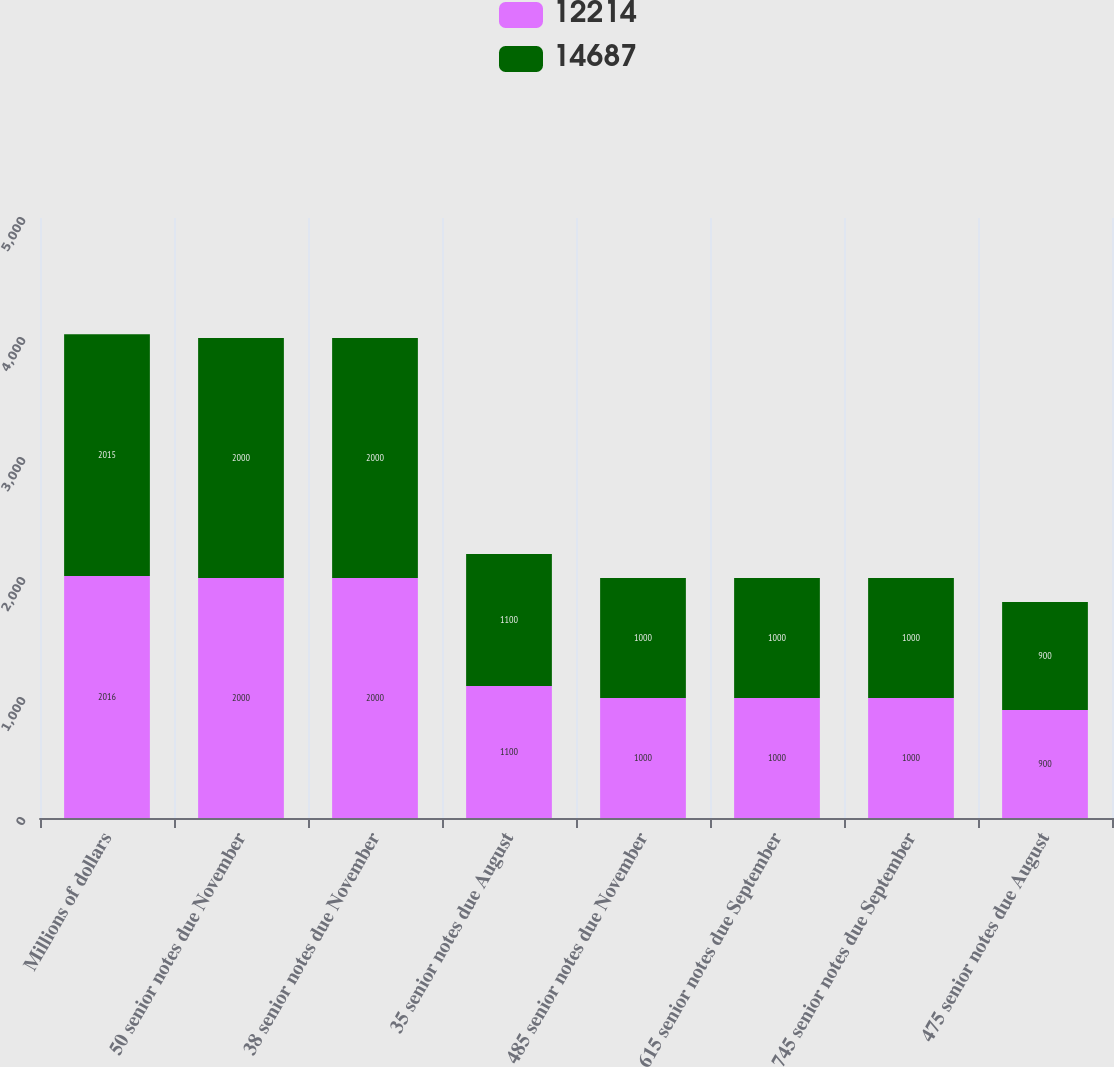<chart> <loc_0><loc_0><loc_500><loc_500><stacked_bar_chart><ecel><fcel>Millions of dollars<fcel>50 senior notes due November<fcel>38 senior notes due November<fcel>35 senior notes due August<fcel>485 senior notes due November<fcel>615 senior notes due September<fcel>745 senior notes due September<fcel>475 senior notes due August<nl><fcel>12214<fcel>2016<fcel>2000<fcel>2000<fcel>1100<fcel>1000<fcel>1000<fcel>1000<fcel>900<nl><fcel>14687<fcel>2015<fcel>2000<fcel>2000<fcel>1100<fcel>1000<fcel>1000<fcel>1000<fcel>900<nl></chart> 